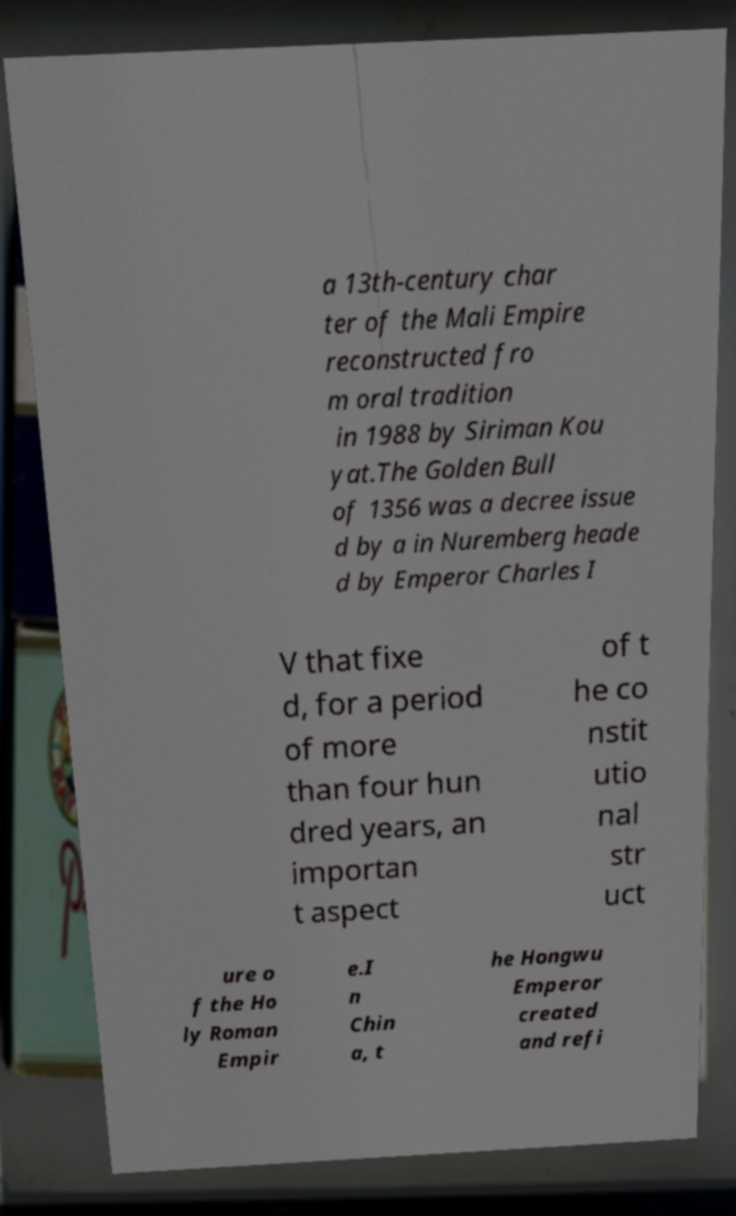For documentation purposes, I need the text within this image transcribed. Could you provide that? a 13th-century char ter of the Mali Empire reconstructed fro m oral tradition in 1988 by Siriman Kou yat.The Golden Bull of 1356 was a decree issue d by a in Nuremberg heade d by Emperor Charles I V that fixe d, for a period of more than four hun dred years, an importan t aspect of t he co nstit utio nal str uct ure o f the Ho ly Roman Empir e.I n Chin a, t he Hongwu Emperor created and refi 